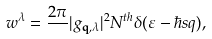Convert formula to latex. <formula><loc_0><loc_0><loc_500><loc_500>w ^ { \lambda } = \frac { 2 \pi } { } | g _ { \mathbf q , \lambda } | ^ { 2 } N ^ { t h } \delta ( \varepsilon - \hbar { s } q ) ,</formula> 